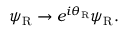Convert formula to latex. <formula><loc_0><loc_0><loc_500><loc_500>\psi _ { R } \rightarrow e ^ { i \theta _ { R } } \psi _ { R } .</formula> 